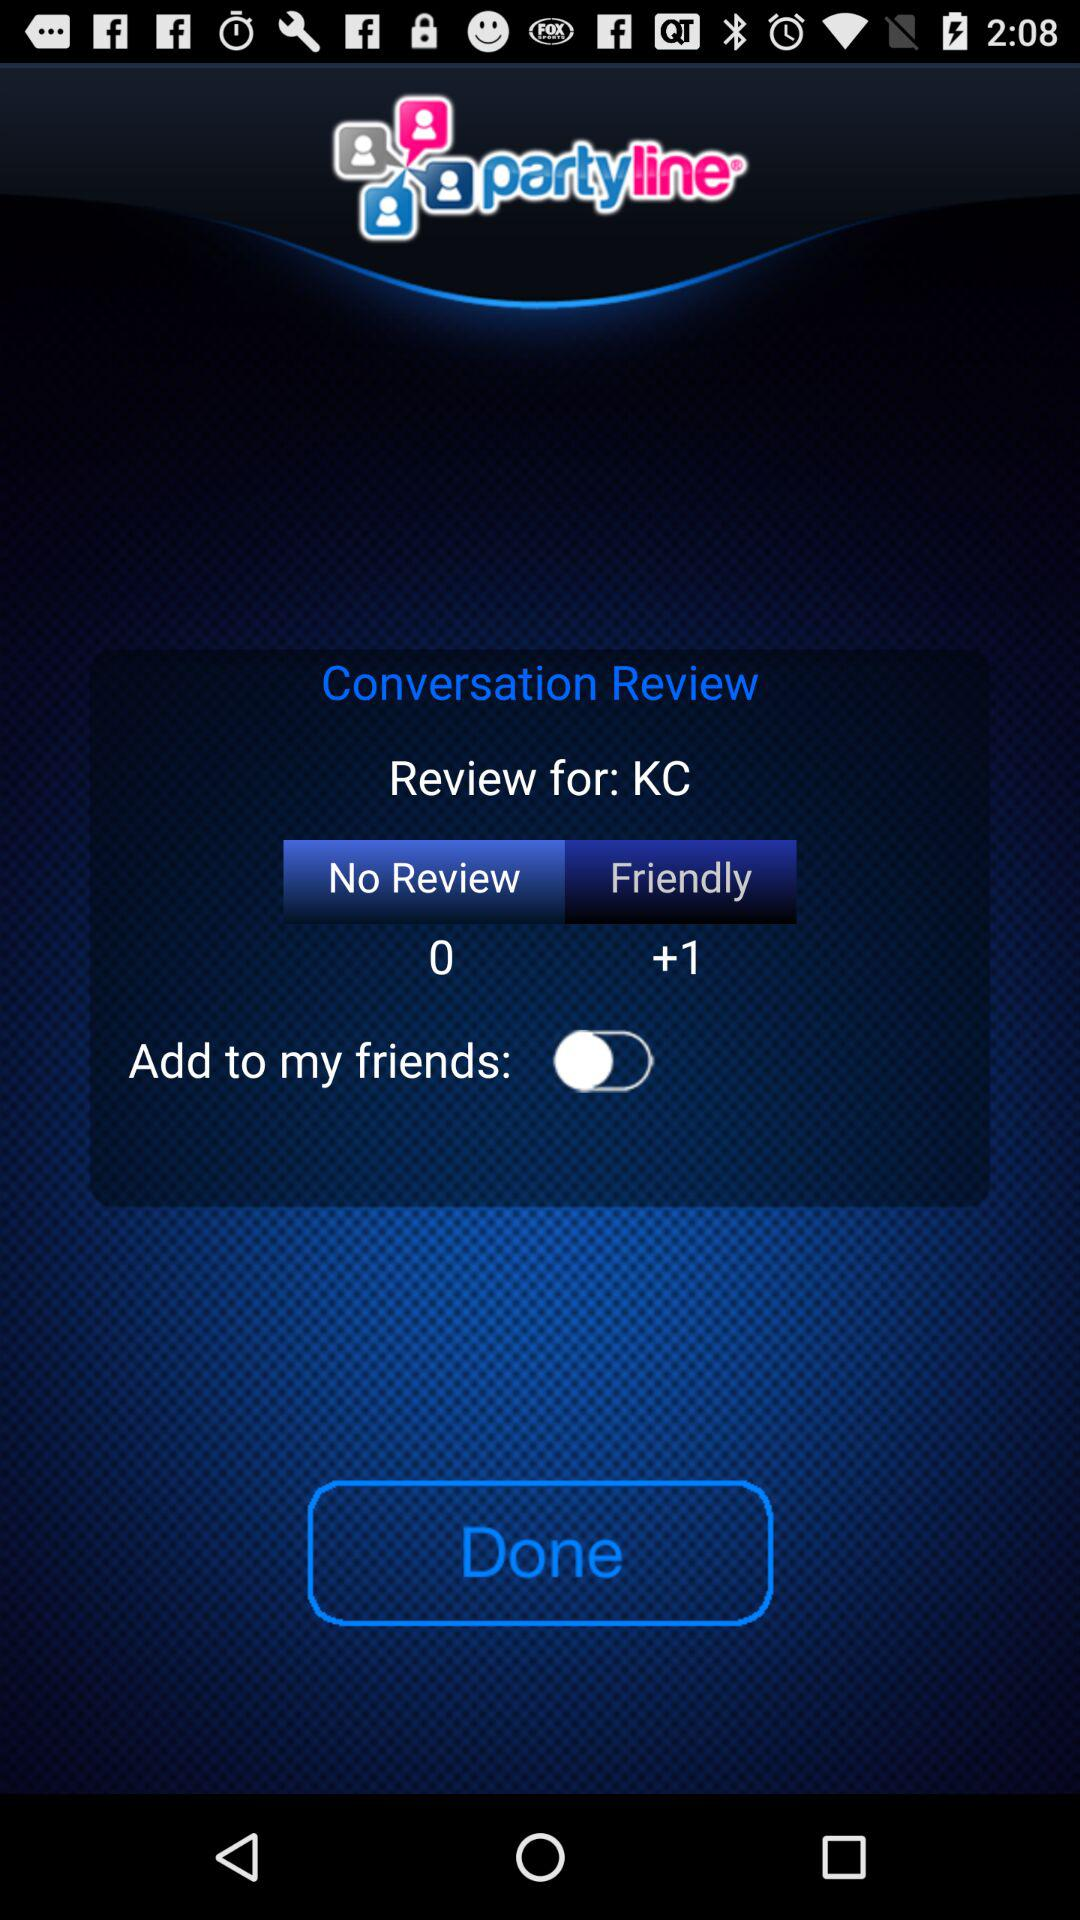How many reviews are there? There are 0 reviews. 